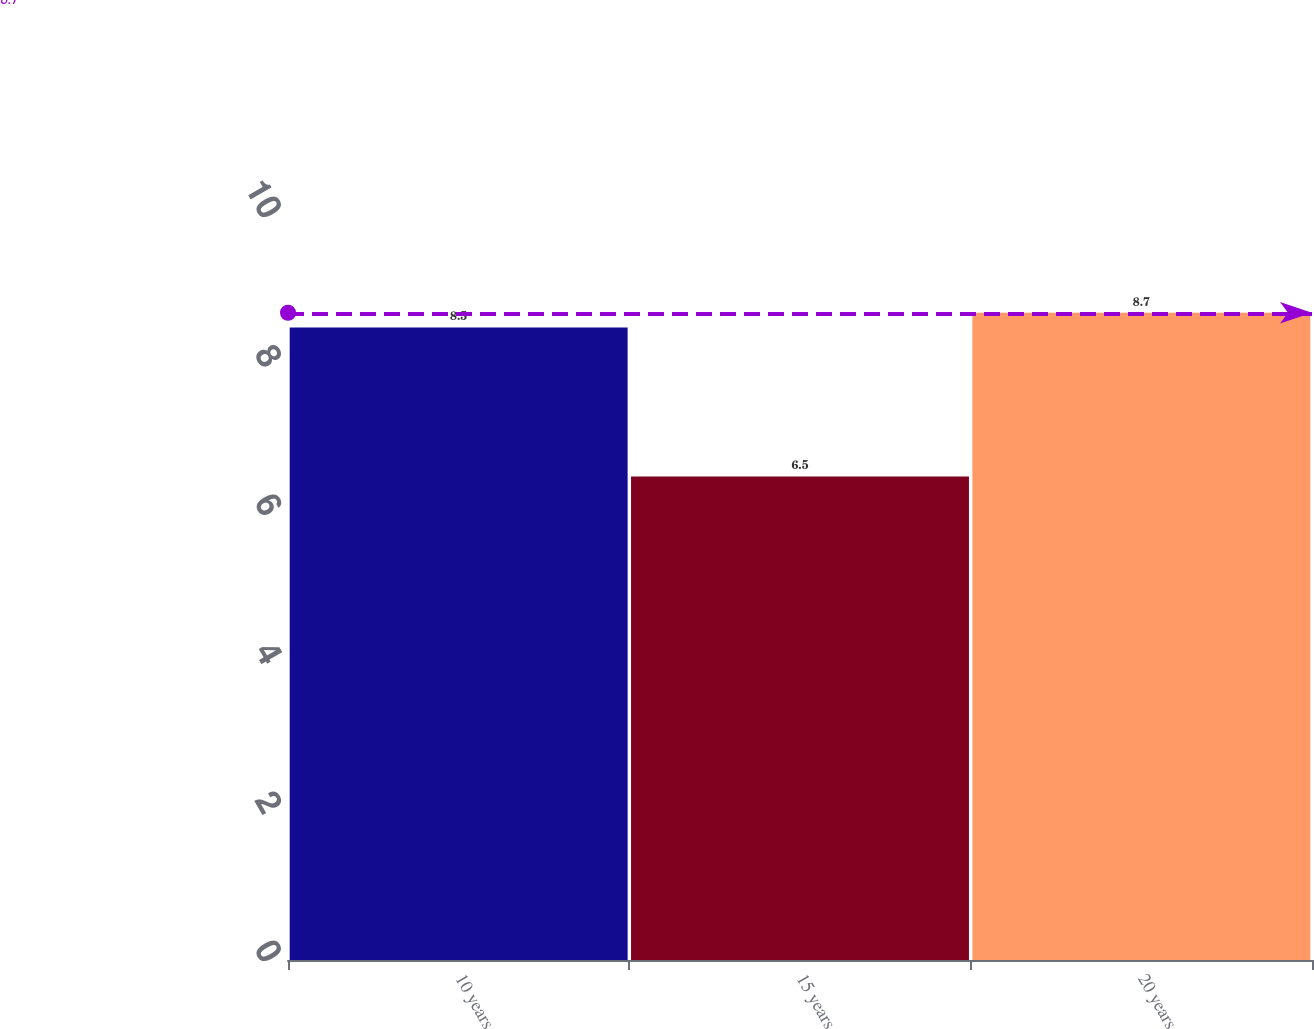Convert chart. <chart><loc_0><loc_0><loc_500><loc_500><bar_chart><fcel>10 years<fcel>15 years<fcel>20 years<nl><fcel>8.5<fcel>6.5<fcel>8.7<nl></chart> 